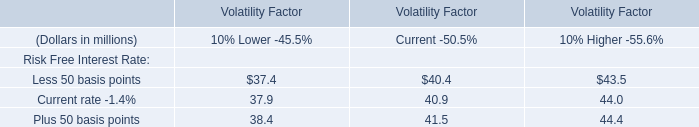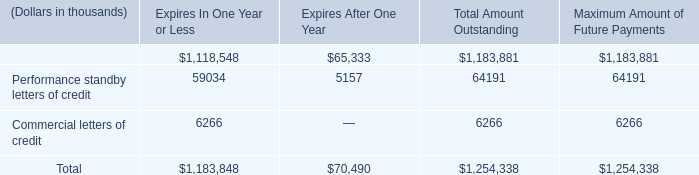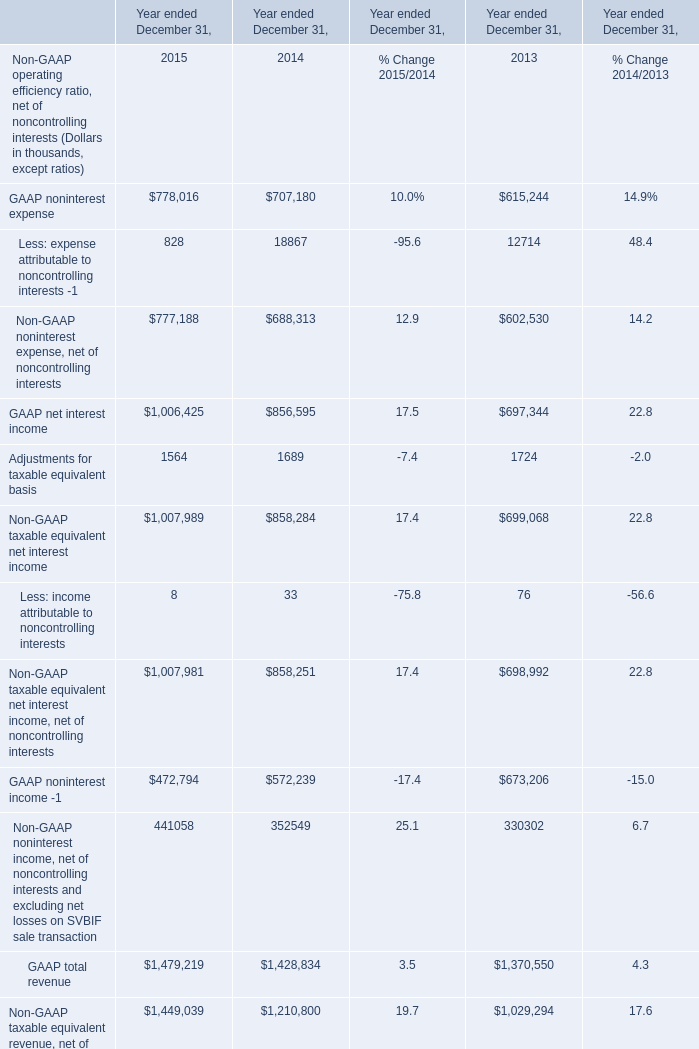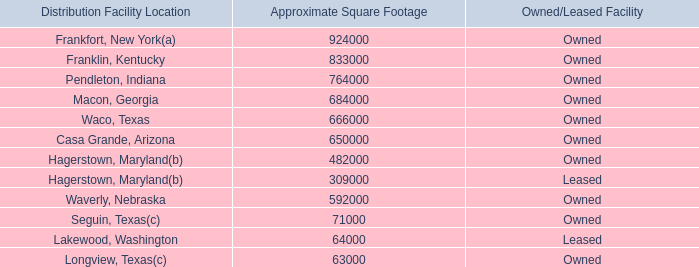what's the total amount of Longview, Texas of Approximate Square Footage, GAAP net interest income of Year ended December 31, 2014, and Financial standby letters of credit of Total Amount Outstanding ? 
Computations: ((63000.0 + 856595.0) + 1183881.0)
Answer: 2103476.0. 